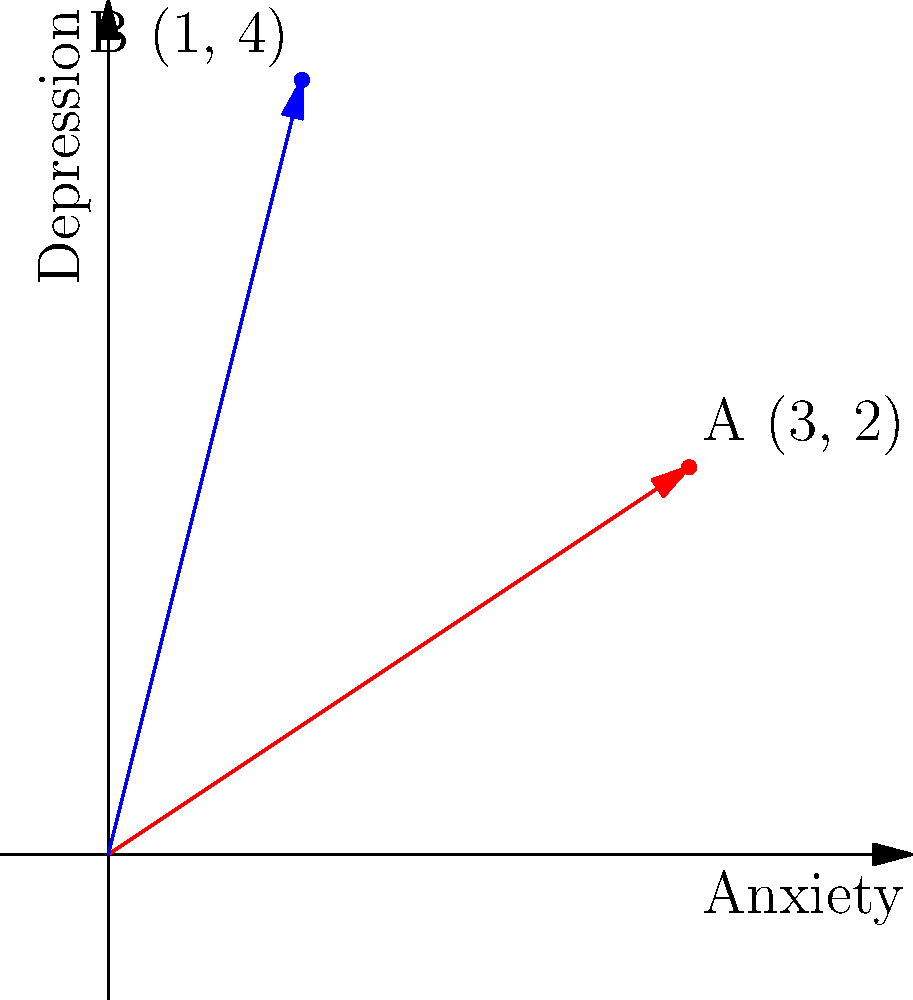In a study on stress levels, two patients' anxiety and depression scores are represented as vectors in a 2D coordinate system. Patient A's stress vector is (3, 2), and Patient B's is (1, 4). Calculate the magnitude of the difference vector between these two stress states. How might this information be useful in assessing relative stress levels and treatment progress? To solve this problem, we'll follow these steps:

1) First, we need to find the difference vector between the two stress states:
   Difference vector = B - A = (1, 4) - (3, 2) = (-2, 2)

2) To calculate the magnitude of this difference vector, we use the Pythagorean theorem:
   Magnitude = $$\sqrt{(-2)^2 + 2^2}$$

3) Simplify:
   Magnitude = $$\sqrt{4 + 4} = \sqrt{8}$$

4) Simplify further:
   Magnitude = $$2\sqrt{2}$$

The magnitude of the difference vector is $$2\sqrt{2}$$.

This information can be useful in assessing relative stress levels and treatment progress in several ways:

1) The magnitude represents the "distance" between the two stress states in the anxiety-depression space. A larger magnitude indicates a greater difference in overall stress levels.

2) The direction of the difference vector shows how the stress state has changed. In this case, moving from A to B involves a decrease in anxiety but an increase in depression.

3) Over time, tracking these vectors can show the trajectory of a patient's stress state, helping to evaluate the effectiveness of interventions.

4) Comparing difference vectors between multiple patients can provide insights into varying responses to treatment or different stress progression patterns.

5) The magnitude can be used as a quantitative measure of overall change in a patient's condition, which can be valuable for statistical analyses in research studies.
Answer: $$2\sqrt{2}$$ 